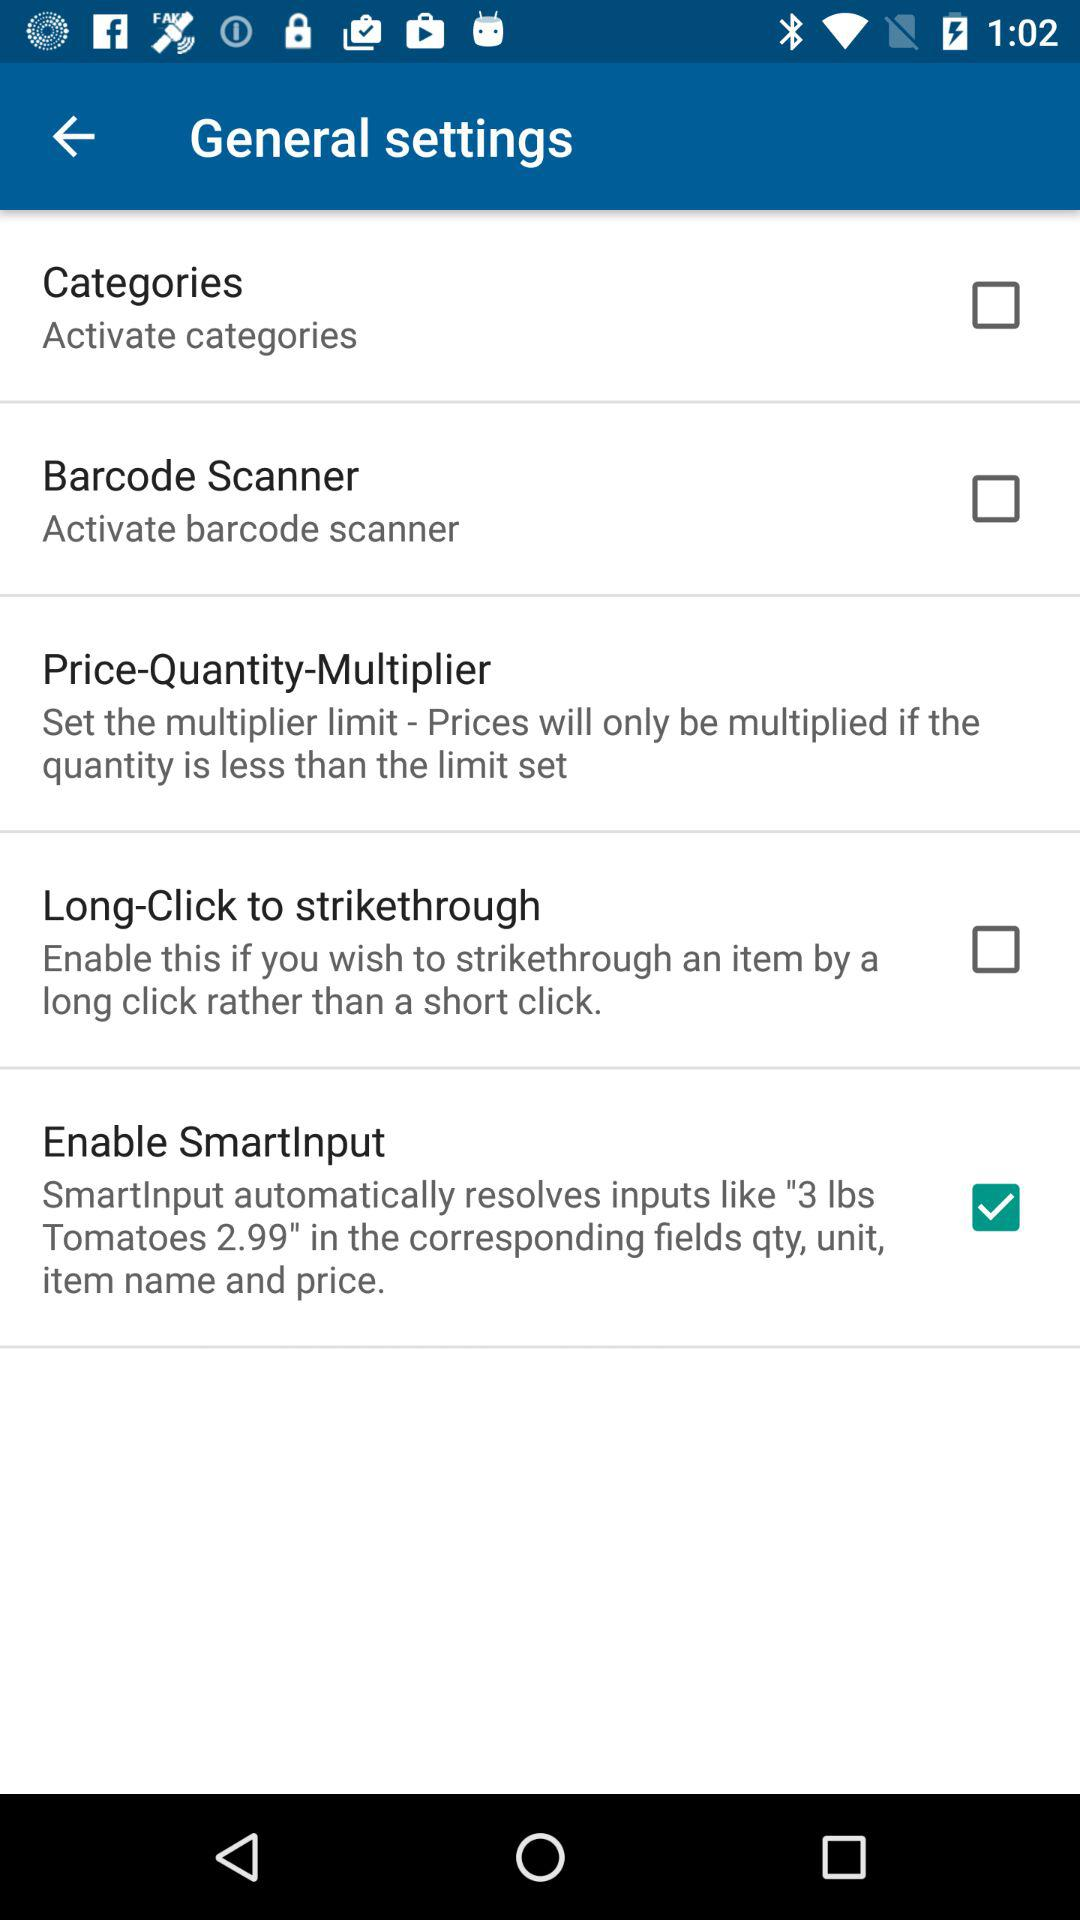What is the status of "Enable SmartInput"? The status of "Enable SmartInput" is "on". 